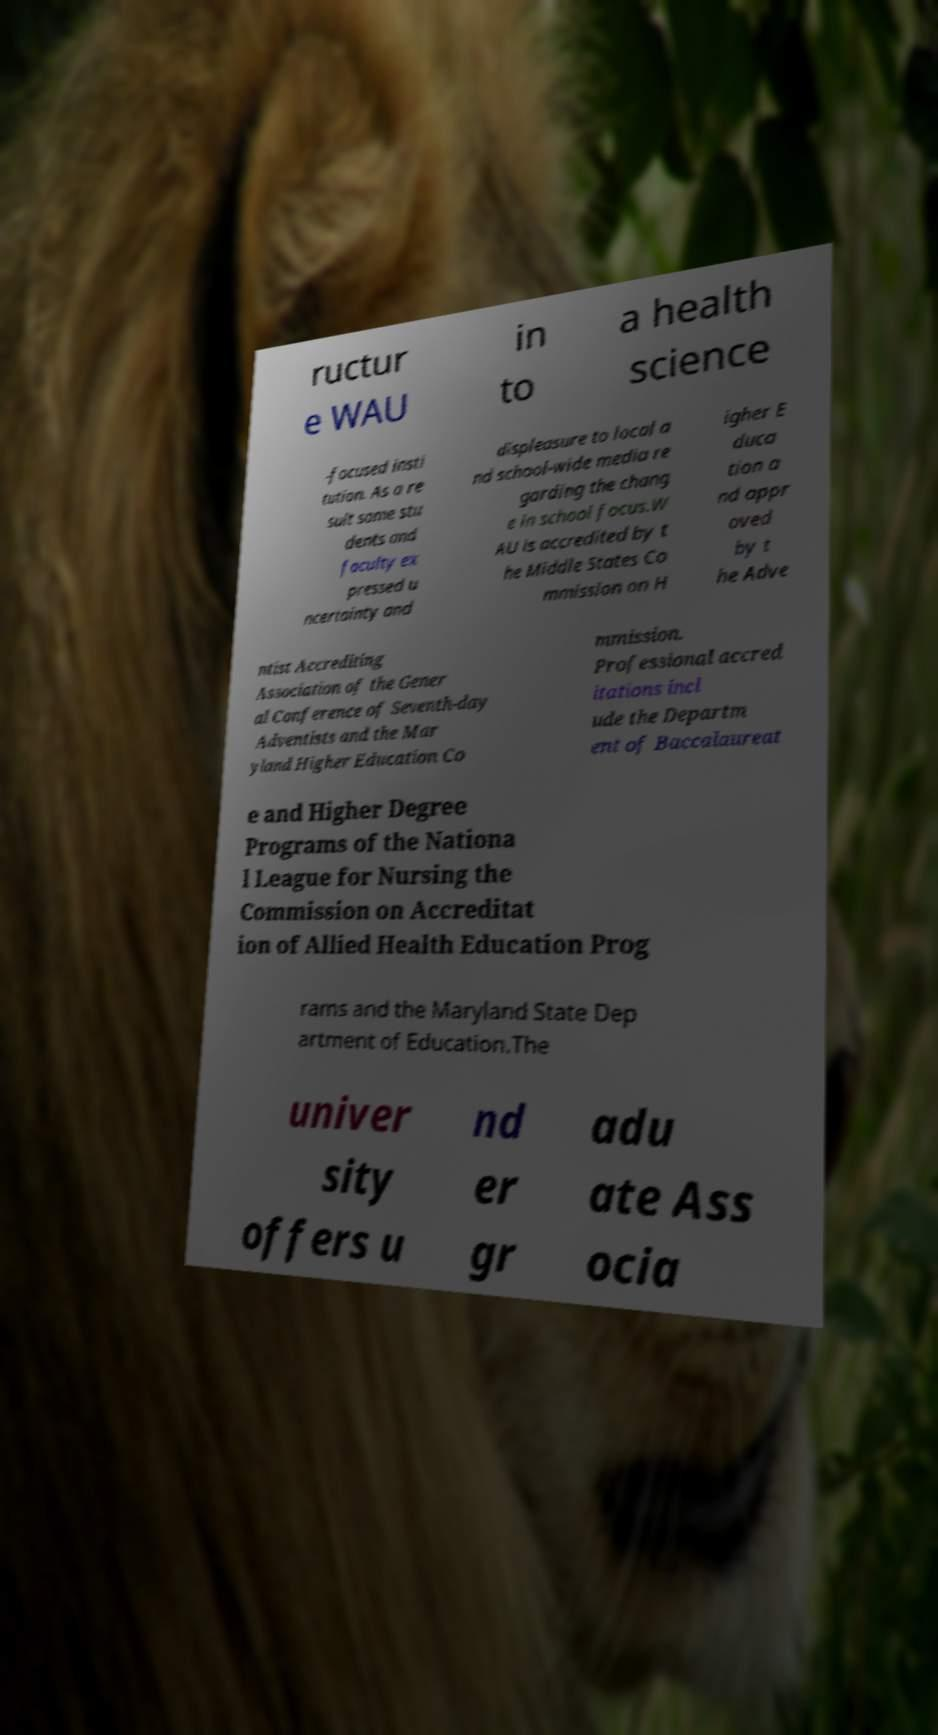Please identify and transcribe the text found in this image. ructur e WAU in to a health science -focused insti tution. As a re sult some stu dents and faculty ex pressed u ncertainty and displeasure to local a nd school-wide media re garding the chang e in school focus.W AU is accredited by t he Middle States Co mmission on H igher E duca tion a nd appr oved by t he Adve ntist Accrediting Association of the Gener al Conference of Seventh-day Adventists and the Mar yland Higher Education Co mmission. Professional accred itations incl ude the Departm ent of Baccalaureat e and Higher Degree Programs of the Nationa l League for Nursing the Commission on Accreditat ion of Allied Health Education Prog rams and the Maryland State Dep artment of Education.The univer sity offers u nd er gr adu ate Ass ocia 